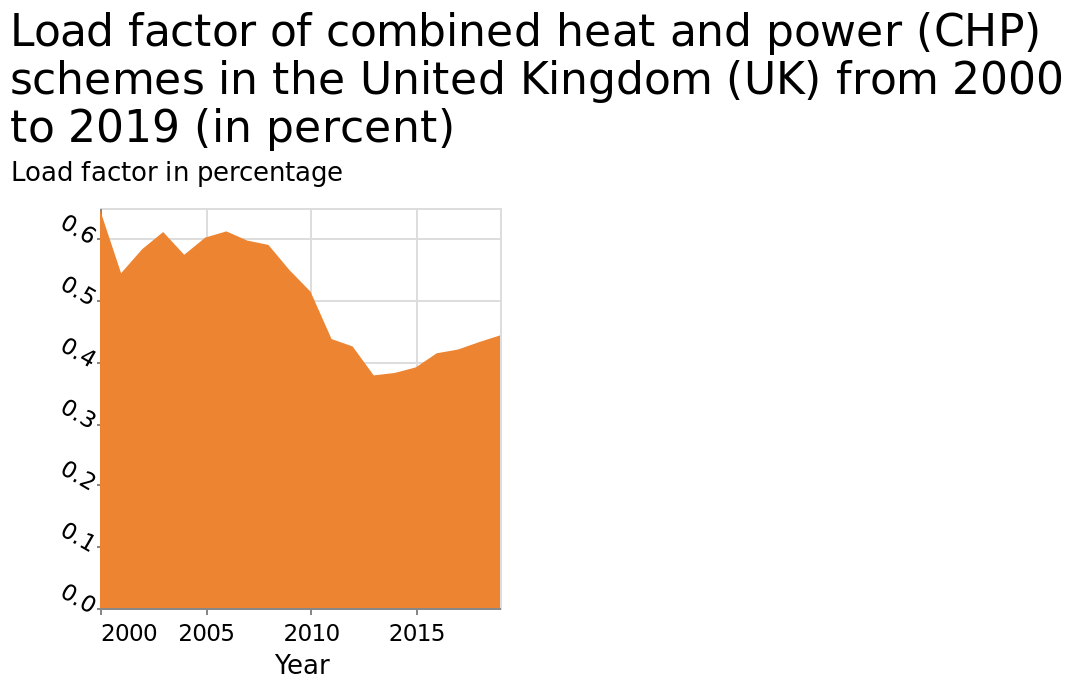<image>
please enumerates aspects of the construction of the chart This area graph is named Load factor of combined heat and power (CHP) schemes in the United Kingdom (UK) from 2000 to 2019 (in percent). Year is drawn as a linear scale with a minimum of 2000 and a maximum of 2015 along the x-axis. Load factor in percentage is defined along a scale with a minimum of 0.0 and a maximum of 0.6 on the y-axis. please summary the statistics and relations of the chart The Load factor of combined heat and power is on an upwards trajectory following 2015. In which country does the data in the area graph represent?  The data in the area graph represents the United Kingdom (UK). 